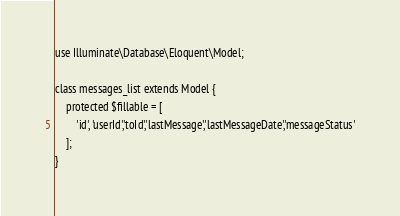Convert code to text. <code><loc_0><loc_0><loc_500><loc_500><_PHP_>use Illuminate\Database\Eloquent\Model;

class messages_list extends Model {
	protected $fillable = [
        'id', 'userId','toId','lastMessage','lastMessageDate','messageStatus'
    ];
}
</code> 